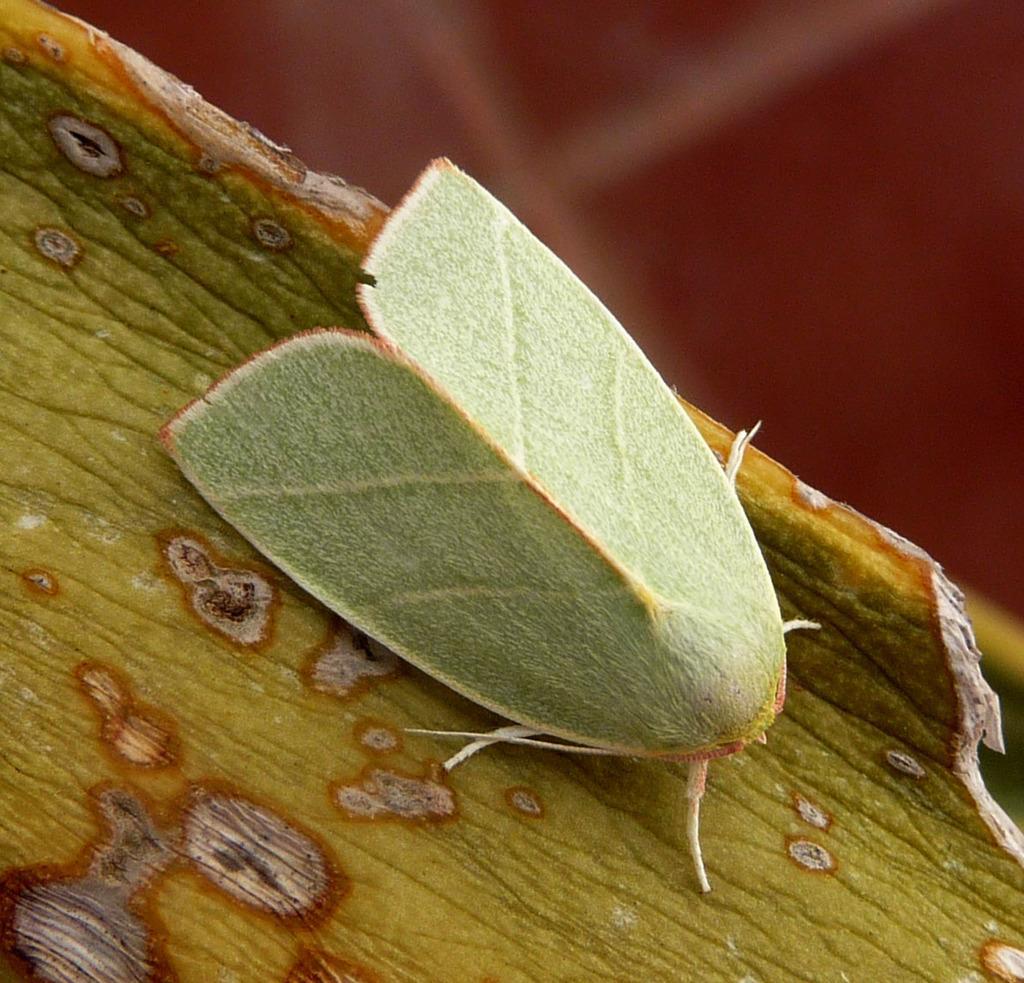How would you summarize this image in a sentence or two? In this picture we can see an insect on the wooden object and in the background we can see it is blurry. 